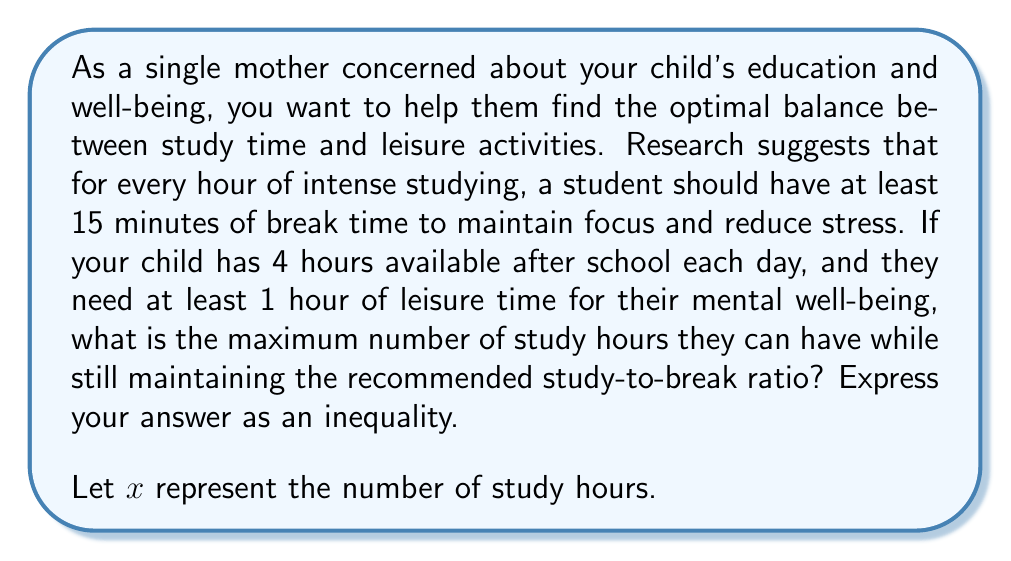Can you solve this math problem? Let's approach this step-by-step:

1) First, we need to consider the constraints:
   - Total available time: 4 hours
   - Minimum leisure time: 1 hour
   - For every hour of study, there should be at least 15 minutes (1/4 hour) of break time

2) Let's express the break time in terms of study time:
   Break time = $\frac{1}{4}x$

3) Now, we can set up an inequality:
   Study time + Break time + Minimum leisure time ≤ Total available time
   $x + \frac{1}{4}x + 1 \leq 4$

4) Simplify the left side of the inequality:
   $\frac{5}{4}x + 1 \leq 4$

5) Subtract 1 from both sides:
   $\frac{5}{4}x \leq 3$

6) Multiply both sides by $\frac{4}{5}$:
   $x \leq \frac{12}{5} = 2.4$

7) Since we're dealing with hours, we need to round down to the nearest whole number or express it as a strict inequality:
   $x \leq 2$

This means your child can study for a maximum of 2 hours while maintaining the recommended study-to-break ratio and having at least 1 hour of leisure time.
Answer: $x \leq 2$, where $x$ represents the number of study hours. 